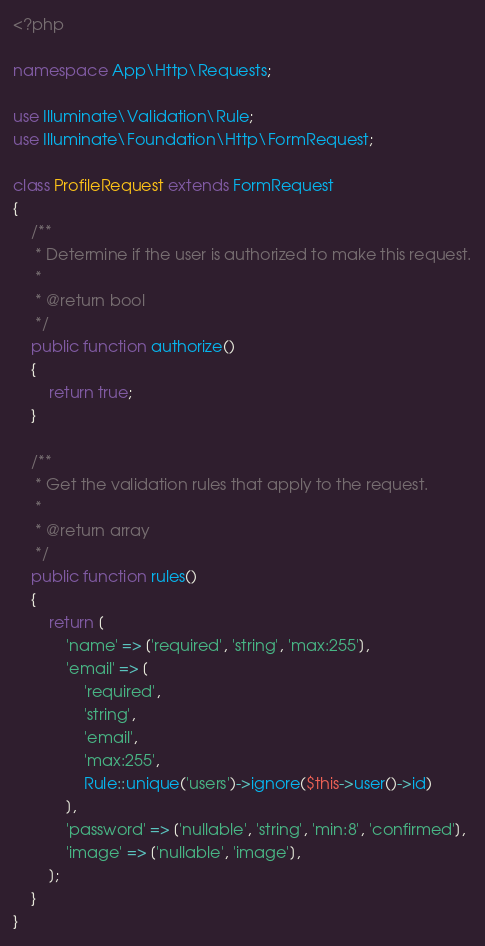<code> <loc_0><loc_0><loc_500><loc_500><_PHP_><?php

namespace App\Http\Requests;

use Illuminate\Validation\Rule;
use Illuminate\Foundation\Http\FormRequest;

class ProfileRequest extends FormRequest
{
    /**
     * Determine if the user is authorized to make this request.
     *
     * @return bool
     */
    public function authorize()
    {
        return true;
    }

    /**
     * Get the validation rules that apply to the request.
     *
     * @return array
     */
    public function rules()
    {
        return [
            'name' => ['required', 'string', 'max:255'],
            'email' => [
                'required',
                'string',
                'email',
                'max:255',
                Rule::unique('users')->ignore($this->user()->id)
            ],
            'password' => ['nullable', 'string', 'min:8', 'confirmed'],
            'image' => ['nullable', 'image'],
        ];
    }
}
</code> 